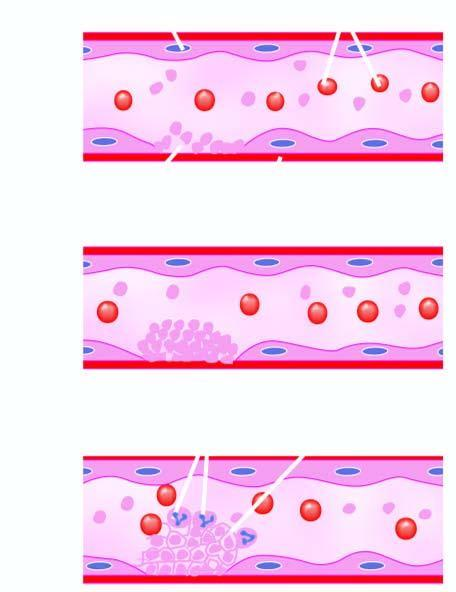what is formed called thrombus?
Answer the question using a single word or phrase. Some leucocytes and red cells and tight meshwork 